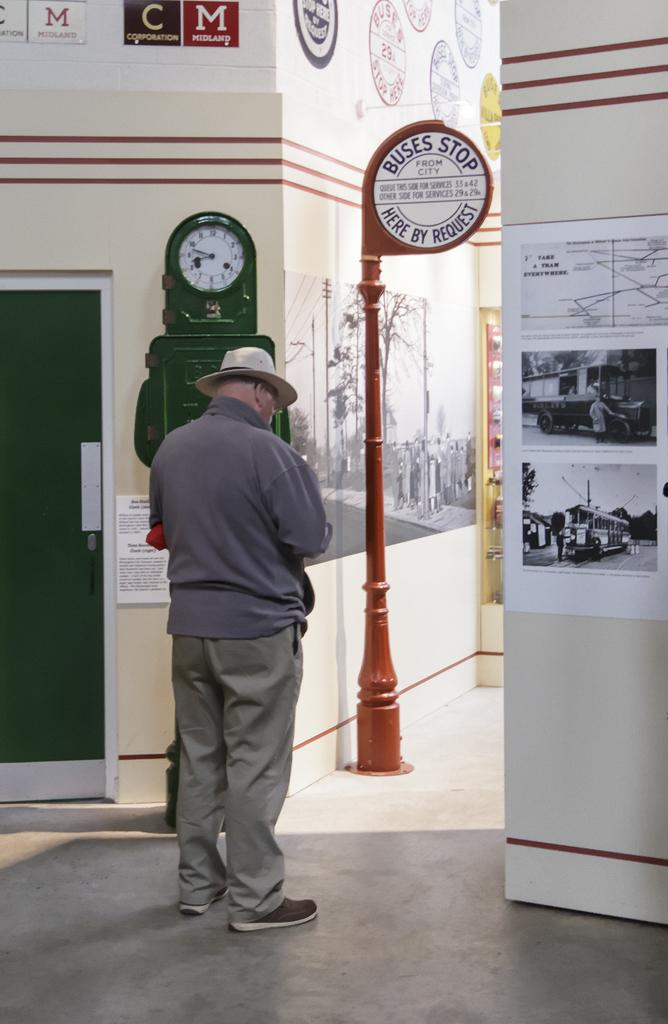Provide a one-sentence caption for the provided image. An older man in front of a sign that says Buses stop here by request. 